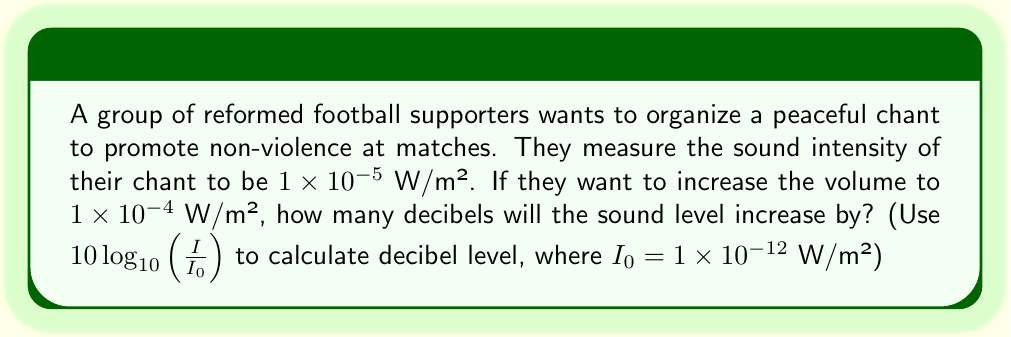Show me your answer to this math problem. Let's approach this step-by-step:

1) We need to calculate the difference in decibel levels between the two sound intensities.

2) The formula for sound level in decibels is:
   $L = 10\log_{10}(\frac{I}{I_0})$

3) Let's calculate the initial sound level:
   $L_1 = 10\log_{10}(\frac{1 \times 10^{-5}}{1 \times 10^{-12}}) = 10\log_{10}(10^7) = 10 \cdot 7 = 70$ dB

4) Now, let's calculate the new sound level:
   $L_2 = 10\log_{10}(\frac{1 \times 10^{-4}}{1 \times 10^{-12}}) = 10\log_{10}(10^8) = 10 \cdot 8 = 80$ dB

5) The increase in decibels is the difference between these two values:
   $\Delta L = L_2 - L_1 = 80 - 70 = 10$ dB

Therefore, the sound level will increase by 10 decibels.
Answer: 10 dB 